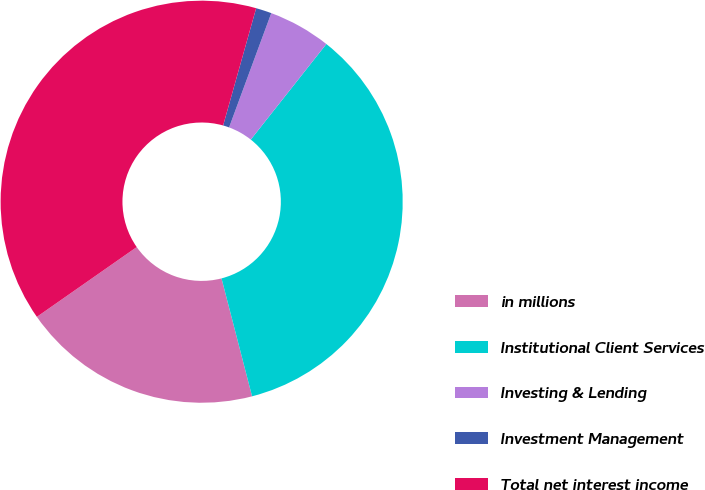Convert chart to OTSL. <chart><loc_0><loc_0><loc_500><loc_500><pie_chart><fcel>in millions<fcel>Institutional Client Services<fcel>Investing & Lending<fcel>Investment Management<fcel>Total net interest income<nl><fcel>19.33%<fcel>35.32%<fcel>5.02%<fcel>1.26%<fcel>39.08%<nl></chart> 